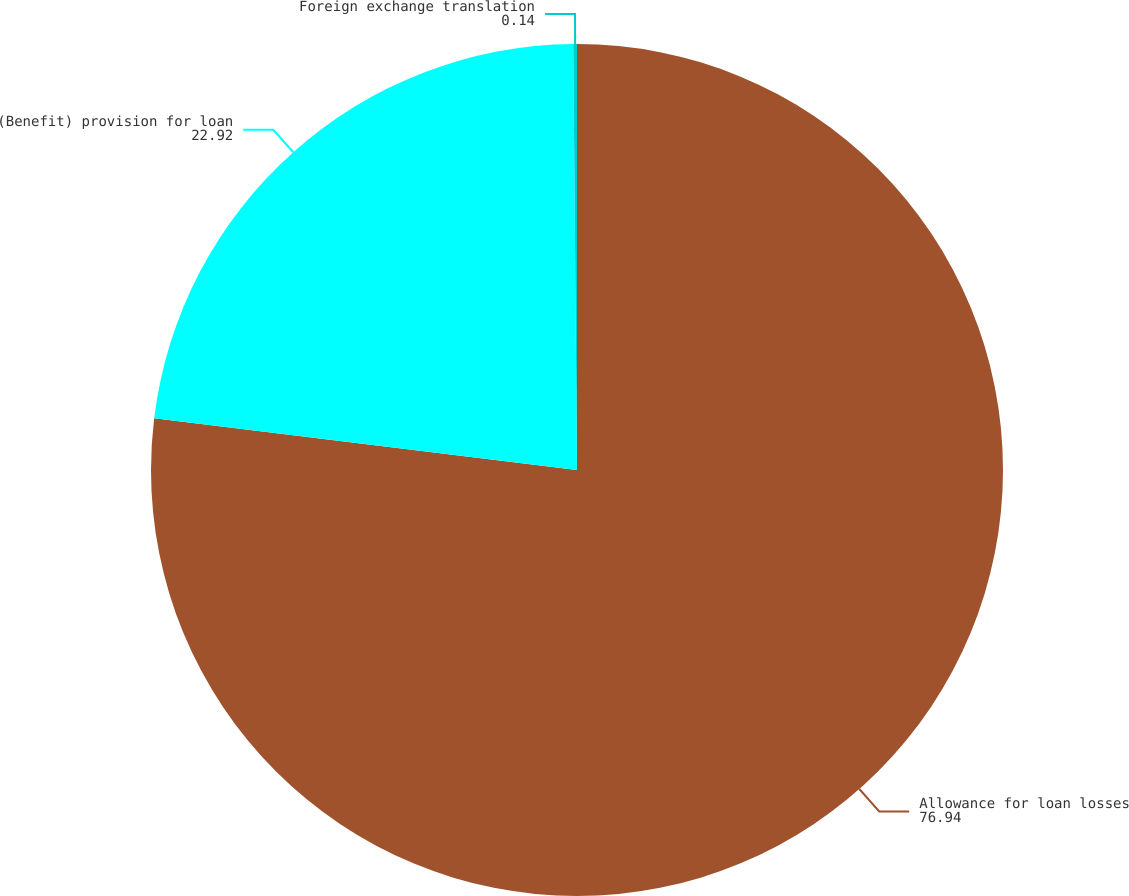Convert chart. <chart><loc_0><loc_0><loc_500><loc_500><pie_chart><fcel>Allowance for loan losses<fcel>(Benefit) provision for loan<fcel>Foreign exchange translation<nl><fcel>76.94%<fcel>22.92%<fcel>0.14%<nl></chart> 